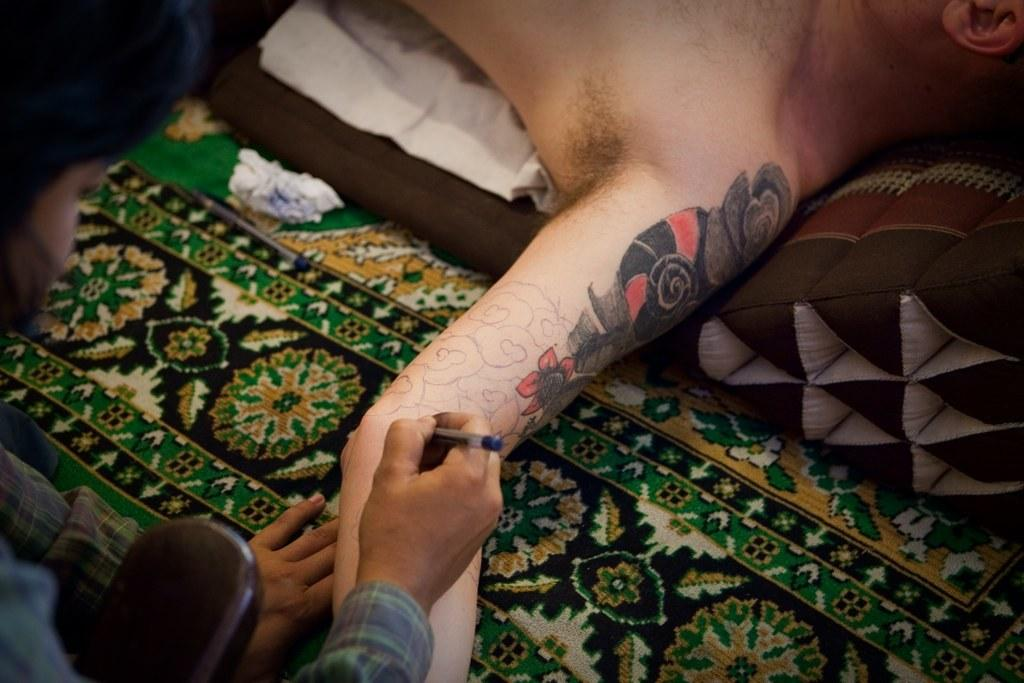What is the person on the bed doing? The person on the bed is lying down. What object can be seen in the image besides the person on the bed? There is a paper napkin in the image. What activity is taking place in the image involving two people? There is a person drawing a design on another person's hand. What type of letter is being sent through the roll in the image? There is no roll or letter present in the image. 